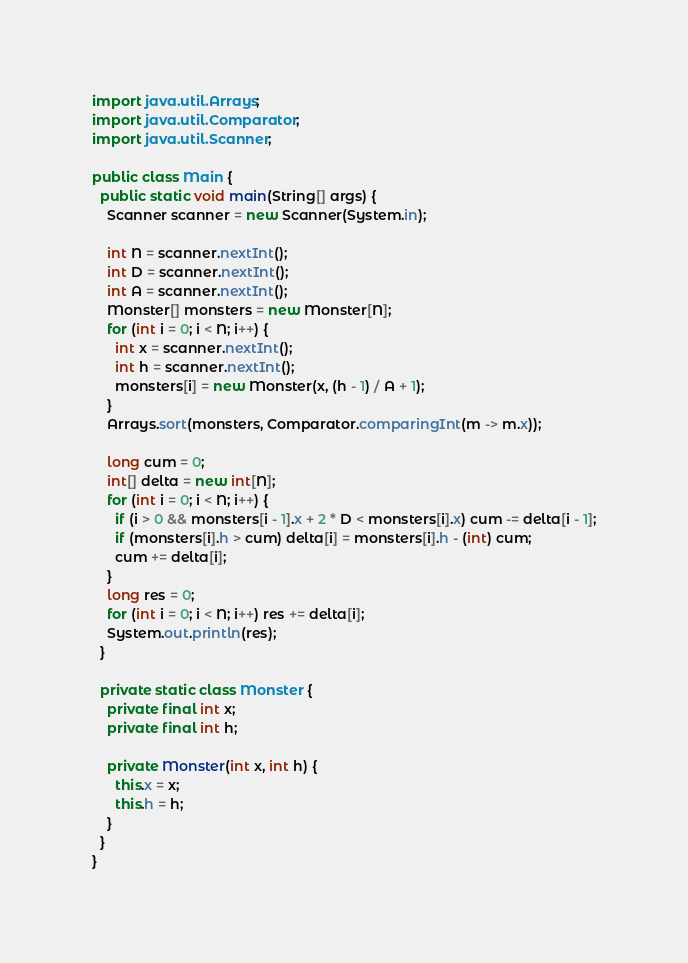Convert code to text. <code><loc_0><loc_0><loc_500><loc_500><_Java_>import java.util.Arrays;
import java.util.Comparator;
import java.util.Scanner;

public class Main {
  public static void main(String[] args) {
    Scanner scanner = new Scanner(System.in);

    int N = scanner.nextInt();
    int D = scanner.nextInt();
    int A = scanner.nextInt();
    Monster[] monsters = new Monster[N];
    for (int i = 0; i < N; i++) {
      int x = scanner.nextInt();
      int h = scanner.nextInt();
      monsters[i] = new Monster(x, (h - 1) / A + 1);
    }
    Arrays.sort(monsters, Comparator.comparingInt(m -> m.x));

    long cum = 0;
    int[] delta = new int[N];
    for (int i = 0; i < N; i++) {
      if (i > 0 && monsters[i - 1].x + 2 * D < monsters[i].x) cum -= delta[i - 1];
      if (monsters[i].h > cum) delta[i] = monsters[i].h - (int) cum;
      cum += delta[i];
    }
    long res = 0;
    for (int i = 0; i < N; i++) res += delta[i];
    System.out.println(res);
  }

  private static class Monster {
    private final int x;
    private final int h;

    private Monster(int x, int h) {
      this.x = x;
      this.h = h;
    }
  }
}
</code> 